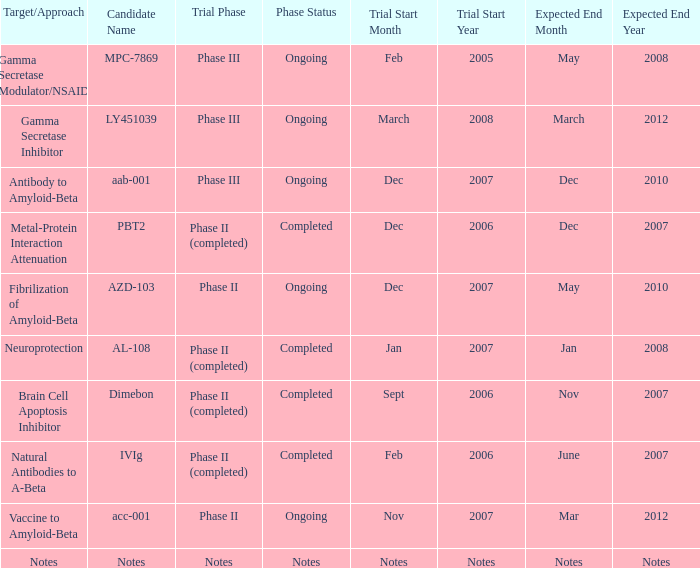Give me the full table as a dictionary. {'header': ['Target/Approach', 'Candidate Name', 'Trial Phase', 'Phase Status', 'Trial Start Month', 'Trial Start Year', 'Expected End Month', 'Expected End Year'], 'rows': [['Gamma Secretase Modulator/NSAID', 'MPC-7869', 'Phase III', 'Ongoing', 'Feb', '2005', 'May', '2008'], ['Gamma Secretase Inhibitor', 'LY451039', 'Phase III', 'Ongoing', 'March', '2008', 'March', '2012'], ['Antibody to Amyloid-Beta', 'aab-001', 'Phase III', 'Ongoing', 'Dec', '2007', 'Dec', '2010'], ['Metal-Protein Interaction Attenuation', 'PBT2', 'Phase II (completed)', 'Completed', 'Dec', '2006', 'Dec', '2007'], ['Fibrilization of Amyloid-Beta', 'AZD-103', 'Phase II', 'Ongoing', 'Dec', '2007', 'May', '2010'], ['Neuroprotection', 'AL-108', 'Phase II (completed)', 'Completed', 'Jan', '2007', 'Jan', '2008'], ['Brain Cell Apoptosis Inhibitor', 'Dimebon', 'Phase II (completed)', 'Completed', 'Sept', '2006', 'Nov', '2007'], ['Natural Antibodies to A-Beta', 'IVIg', 'Phase II (completed)', 'Completed', 'Feb', '2006', 'June', '2007'], ['Vaccine to Amyloid-Beta', 'acc-001', 'Phase II', 'Ongoing', 'Nov', '2007', 'Mar', '2012'], ['Notes', 'Notes', 'Notes', 'Notes', 'Notes', 'Notes', 'Notes', 'Notes']]} In the case of notes being the target/approach, what is the estimated date of conclusion? Notes. 